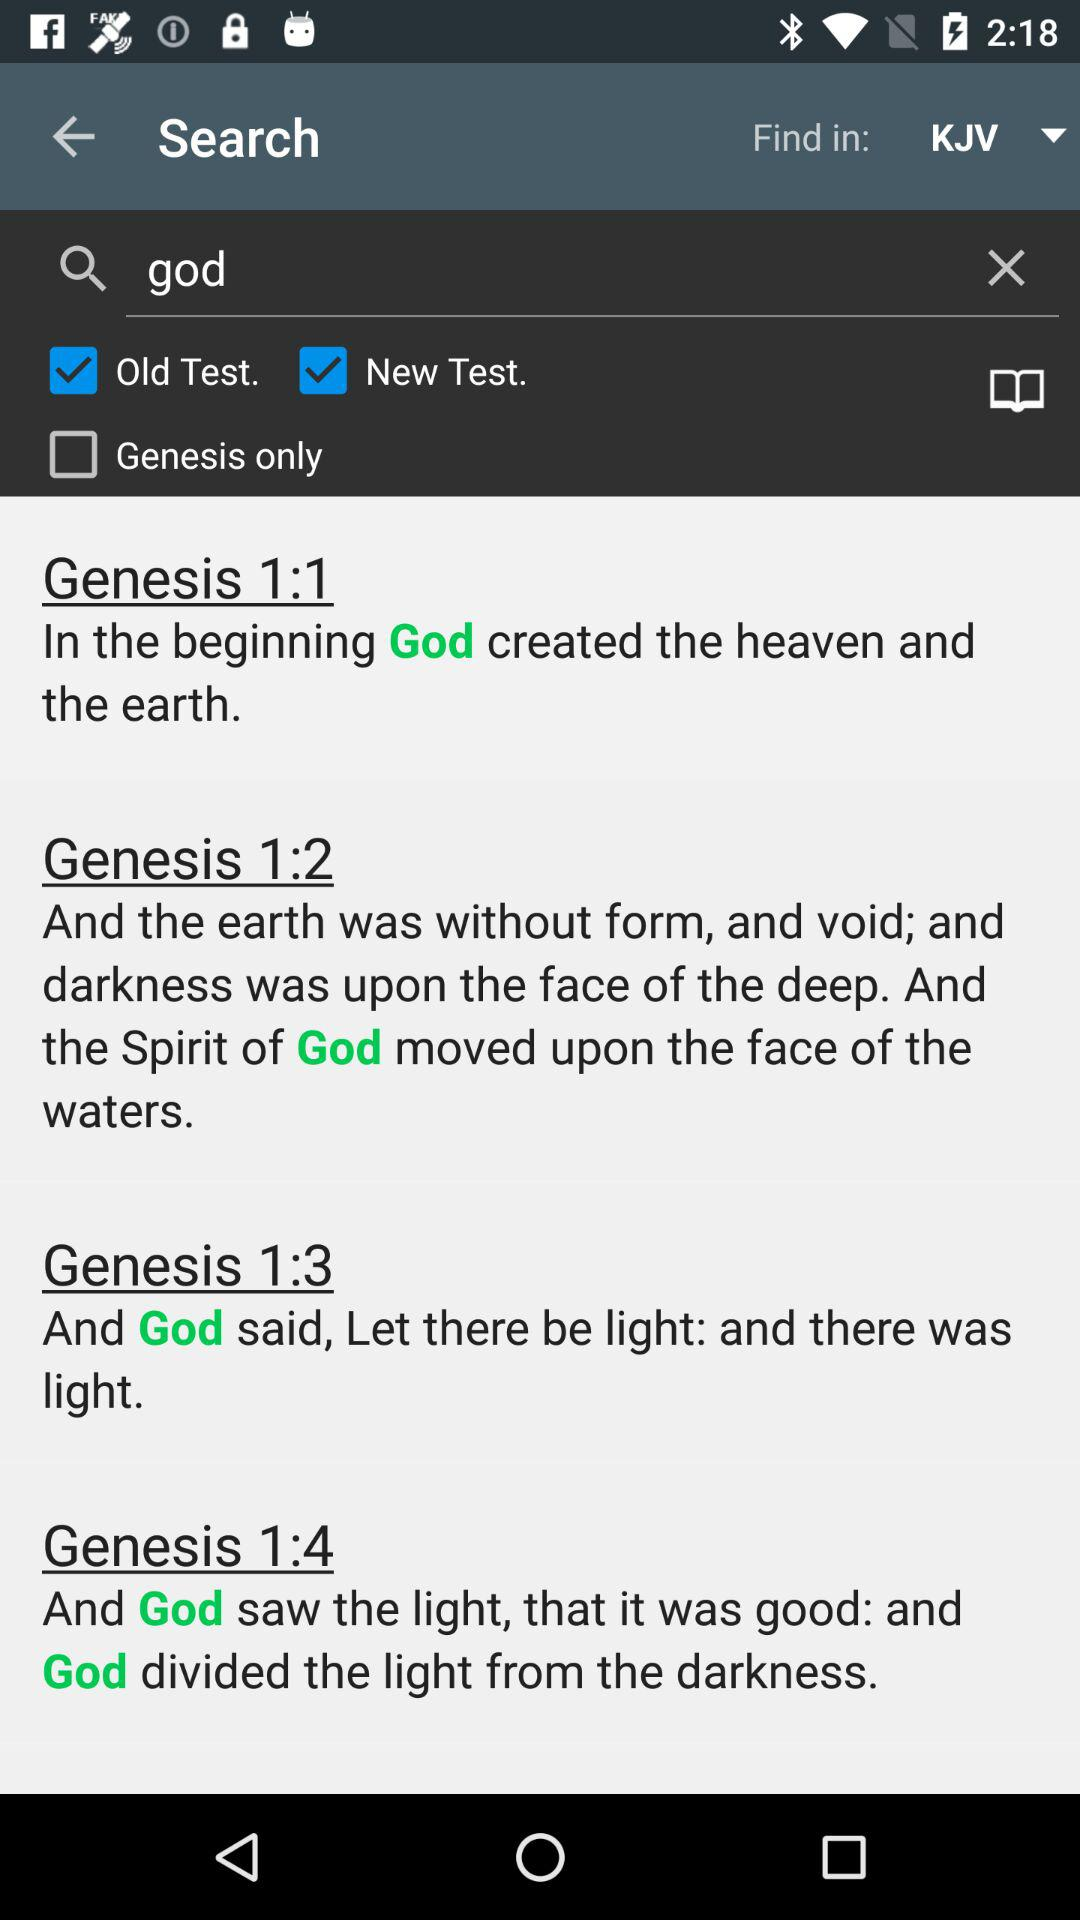What is the status of "Genesis only"? The status is "off". 